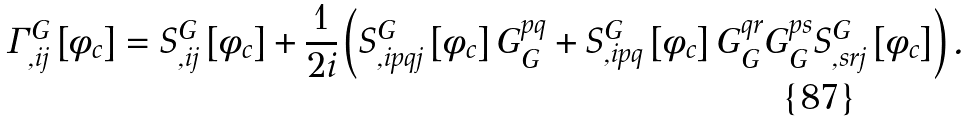<formula> <loc_0><loc_0><loc_500><loc_500>\Gamma _ { , i j } ^ { G } \left [ \phi _ { c } \right ] = S _ { , i j } ^ { G } \left [ \phi _ { c } \right ] + \frac { 1 } { 2 i } \left ( S _ { , i p q j } ^ { G } \left [ \phi _ { c } \right ] G _ { G } ^ { p q } + S _ { , i p q } ^ { G } \left [ \phi _ { c } \right ] G _ { G } ^ { q r } G _ { G } ^ { p s } S _ { , s r j } ^ { G } \left [ \phi _ { c } \right ] \right ) .</formula> 